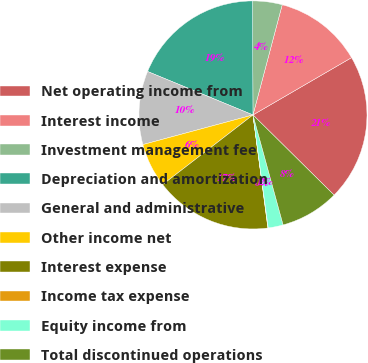Convert chart to OTSL. <chart><loc_0><loc_0><loc_500><loc_500><pie_chart><fcel>Net operating income from<fcel>Interest income<fcel>Investment management fee<fcel>Depreciation and amortization<fcel>General and administrative<fcel>Other income net<fcel>Interest expense<fcel>Income tax expense<fcel>Equity income from<fcel>Total discontinued operations<nl><fcel>20.78%<fcel>12.49%<fcel>4.19%<fcel>18.71%<fcel>10.41%<fcel>6.27%<fcel>16.63%<fcel>0.05%<fcel>2.12%<fcel>8.34%<nl></chart> 